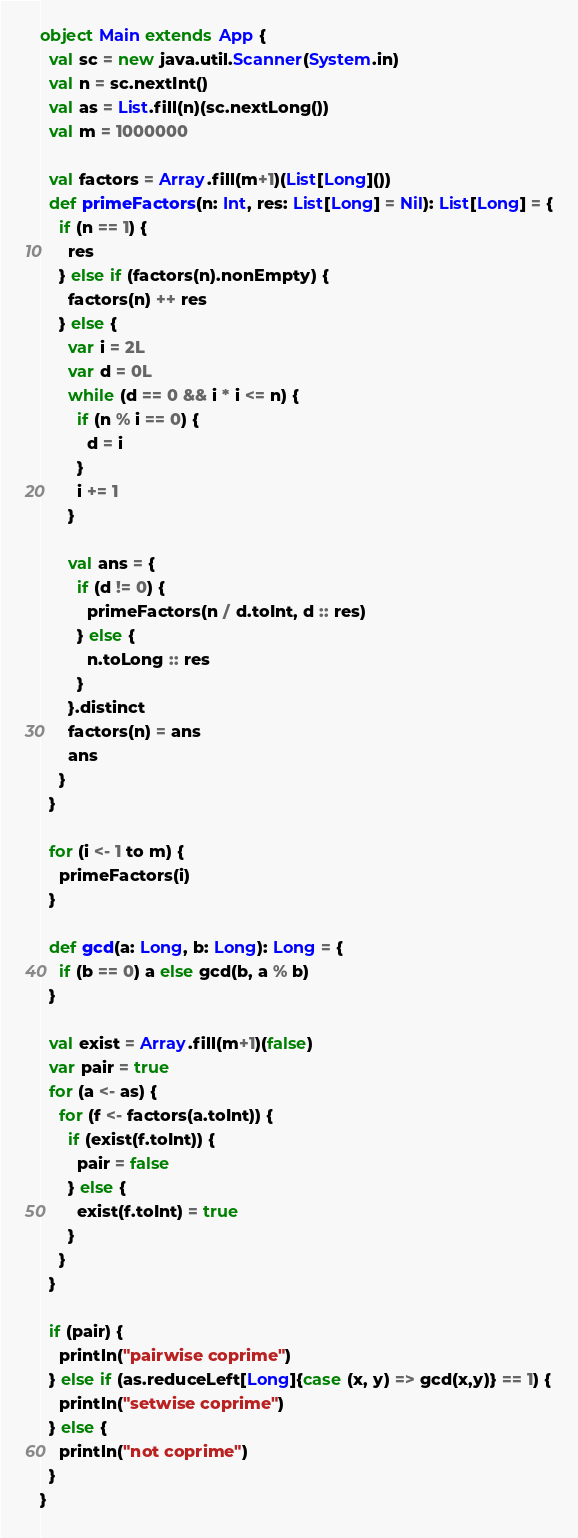<code> <loc_0><loc_0><loc_500><loc_500><_Scala_>object Main extends App {
  val sc = new java.util.Scanner(System.in)
  val n = sc.nextInt()
  val as = List.fill(n)(sc.nextLong())
  val m = 1000000

  val factors = Array.fill(m+1)(List[Long]())
  def primeFactors(n: Int, res: List[Long] = Nil): List[Long] = {
    if (n == 1) {
      res
    } else if (factors(n).nonEmpty) {
      factors(n) ++ res
    } else {
      var i = 2L
      var d = 0L
      while (d == 0 && i * i <= n) {
        if (n % i == 0) {
          d = i
        }
        i += 1
      }

      val ans = {
        if (d != 0) {
          primeFactors(n / d.toInt, d :: res)
        } else {
          n.toLong :: res
        }
      }.distinct
      factors(n) = ans
      ans
    }
  }

  for (i <- 1 to m) {
    primeFactors(i)
  }

  def gcd(a: Long, b: Long): Long = {
    if (b == 0) a else gcd(b, a % b)
  }

  val exist = Array.fill(m+1)(false)
  var pair = true
  for (a <- as) {
    for (f <- factors(a.toInt)) {
      if (exist(f.toInt)) {
        pair = false
      } else {
        exist(f.toInt) = true
      }
    }
  }

  if (pair) {
    println("pairwise coprime")
  } else if (as.reduceLeft[Long]{case (x, y) => gcd(x,y)} == 1) {
    println("setwise coprime")
  } else {
    println("not coprime")
  }
}
</code> 